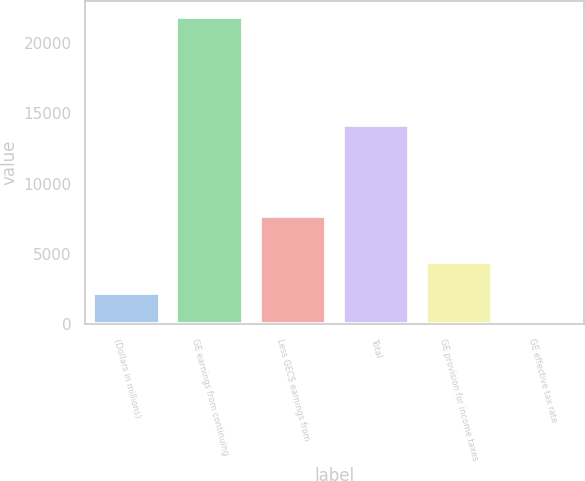Convert chart to OTSL. <chart><loc_0><loc_0><loc_500><loc_500><bar_chart><fcel>(Dollars in millions)<fcel>GE earnings from continuing<fcel>Less GECS earnings from<fcel>Total<fcel>GE provision for income taxes<fcel>GE effective tax rate<nl><fcel>2208.18<fcel>21864<fcel>7712<fcel>14152<fcel>4392.16<fcel>24.2<nl></chart> 